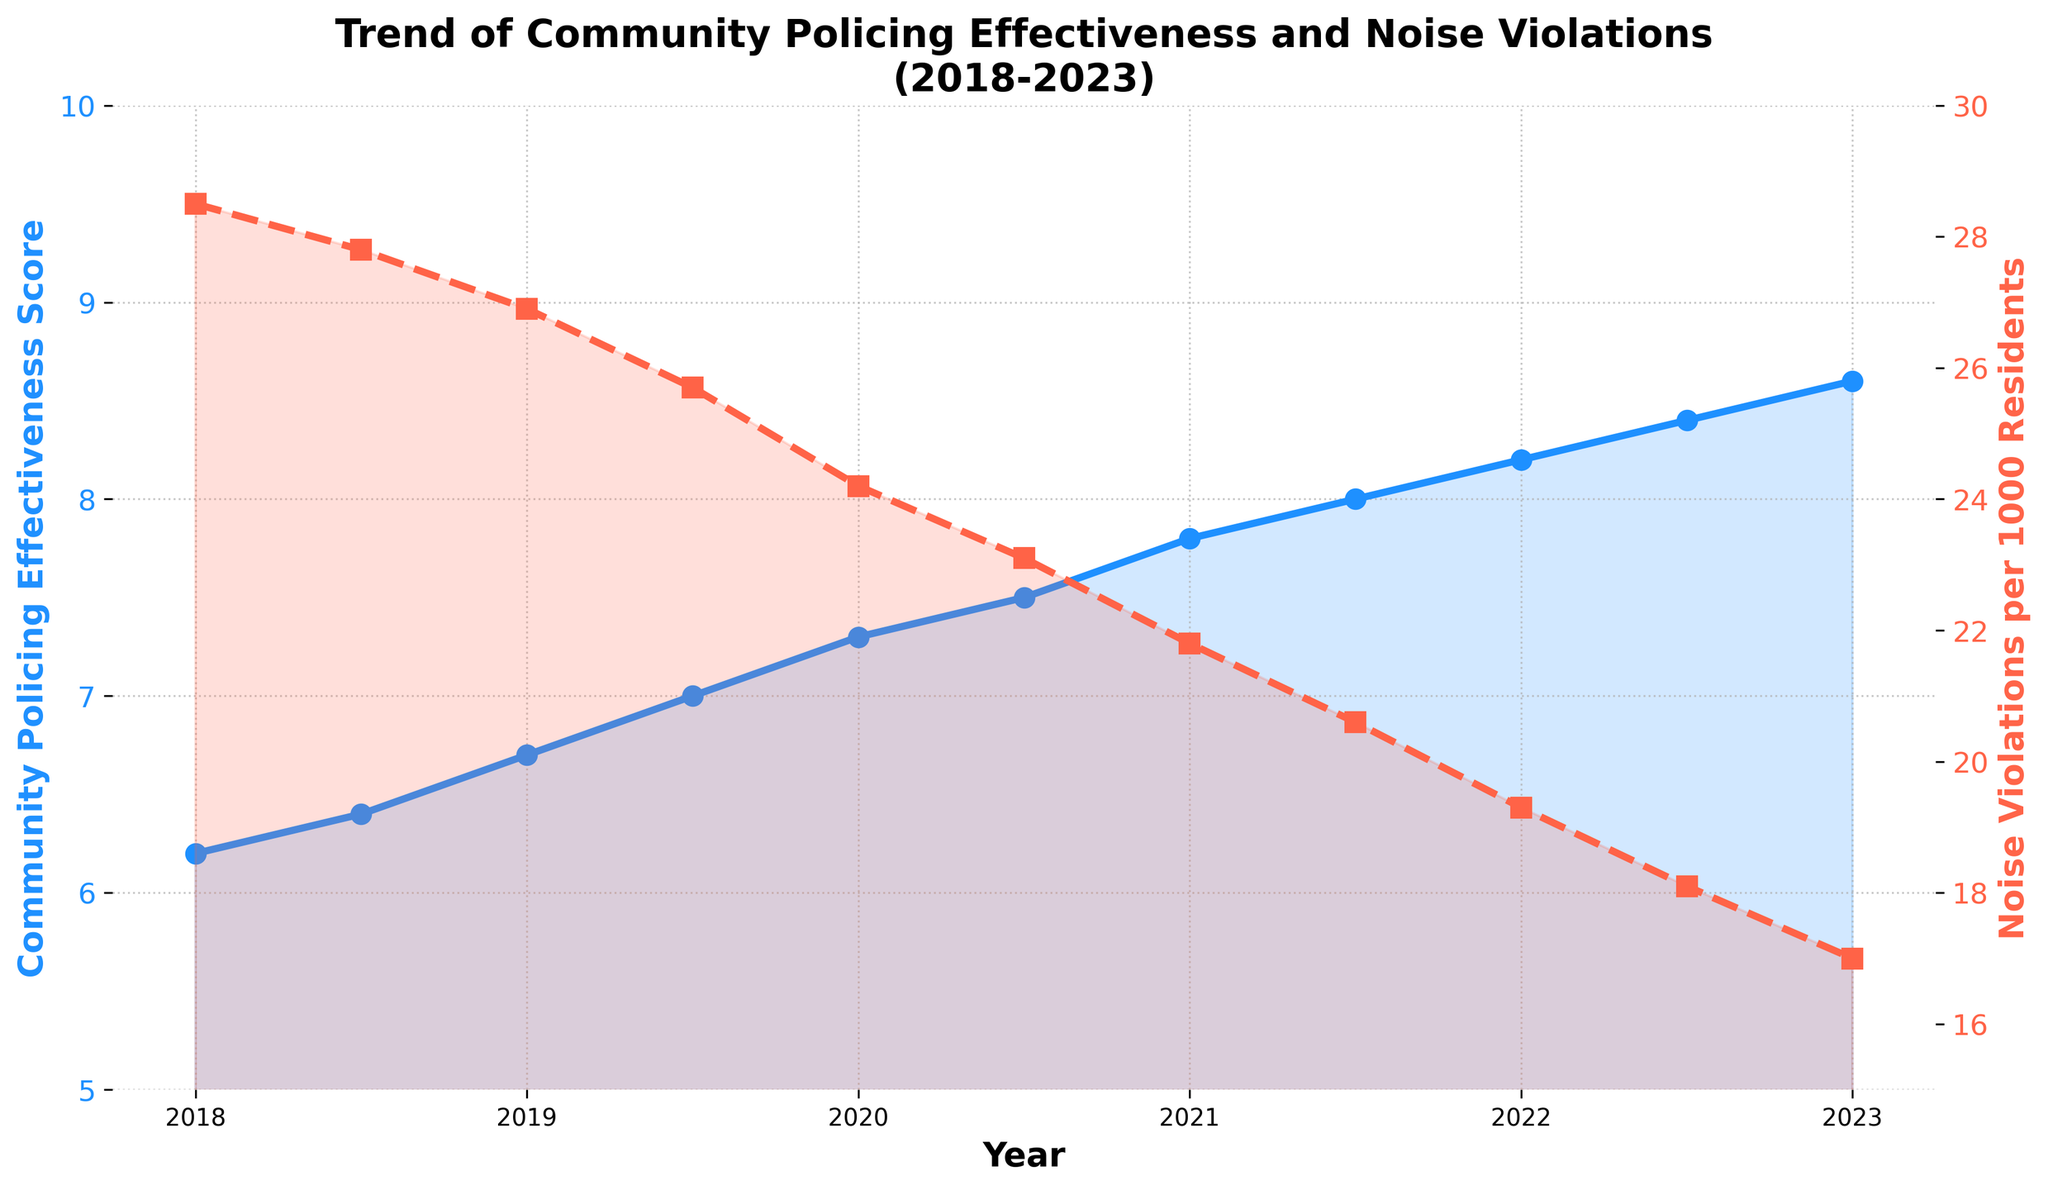What is the trend for the Community Policing Effectiveness Score from 2018 to 2023? The plot shows that the Community Policing Effectiveness Score increases consistently from 6.2 in 2018 to 8.6 in 2023.
Answer: Increasing How many Noise Violations per 1000 Residents were there in mid-2021? According to the plot, in mid-2021 (2021.5), there were 20.6 Noise Violations per 1000 residents.
Answer: 20.6 By how much did the Community Policing Effectiveness Score increase from 2018 to 2023? To find the increase, subtract the 2018 score from the 2023 score: 8.6 - 6.2 = 2.4.
Answer: 2.4 What is the relationship between the Community Policing Effectiveness Score and Noise Violations per 1000 Residents? The plot shows an inverse relationship; as the Community Policing Effectiveness Score increases, the Noise Violations per 1000 Residents decrease.
Answer: Inverse relationship In which year did the Noise Violations per 1000 Residents fall below 20 for the first time? According to the plot, the Noise Violations per 1000 Residents fell below 20 for the first time in 2022.5.
Answer: 2022.5 By how much did Noise Violations per 1000 Residents decrease from 2018 to 2023? Calculate the decrease by subtracting the 2023 value from the 2018 value: 28.5 - 17.0 = 11.5.
Answer: 11.5 In mid-2020, which measure was higher than its corresponding value in mid-2019: the Community Policing Effectiveness Score or Noise Violations per 1000 Residents? In mid-2020, the Community Policing Effectiveness Score (7.5) was higher than its value in mid-2019 (7.0), while Noise Violations per 1000 Residents (23.1) were lower than their mid-2019 value (25.7). Therefore, the Community Policing Effectiveness Score was higher.
Answer: Community Policing Effectiveness Score What can be said about the trend in Noise Violations per 1000 Residents as the Community Policing Effectiveness Score approaches 8.6? As the Community Policing Effectiveness Score approaches 8.6, Noise Violations per 1000 Residents show a decreasing trend, eventually reaching 17.0.
Answer: Decreasing trend What visual attributes distinguish the Community Policing Effectiveness Score line from the Noise Violations per 1000 Residents line? The Community Policing Effectiveness Score line is solid and blue with circle markers, while the Noise Violations per 1000 Residents line is dashed and red with square markers.
Answer: Solid blue line, circle markers; Dashed red line, square markers If the trend in the Community Policing Effectiveness Score continues, what would you predict the score to be in mid-2024? The pattern suggests a continuous linear increase. From 2022.5 (8.4) to 2023 (8.6) is a 0.2 increase in half a year, implying a similar half-yearly increase. Therefore, in mid-2024, the score could be predicted to be 8.6 + (2 * 0.2) = 9.0.
Answer: 9.0 